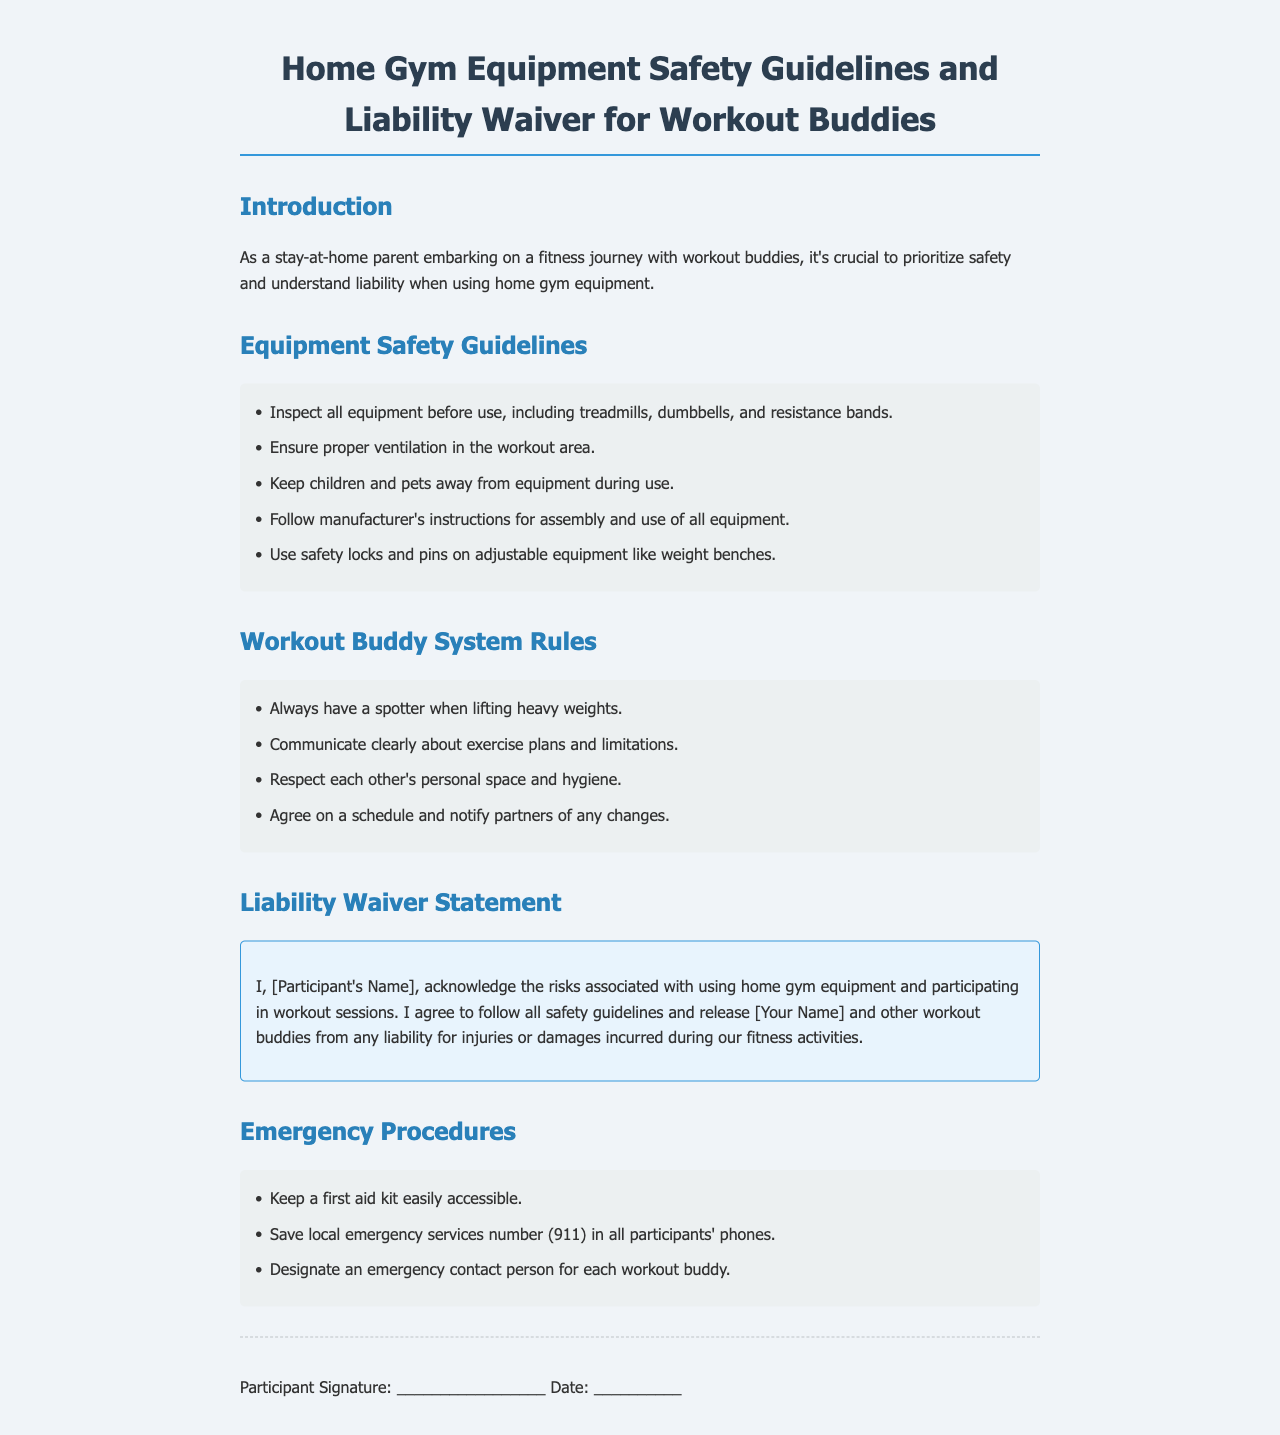what is the title of the document? The title indicates the main subject and purpose of the document, which is about safety guidelines and liability for workout buddies using home gym equipment.
Answer: Home Gym Equipment Safety Guidelines and Liability Waiver for Workout Buddies how many items are listed under Equipment Safety Guidelines? The number of items indicates the comprehensiveness of the safety guidelines provided in the document, which helps ensure proper use of the equipment.
Answer: 5 what is one of the emergency procedures mentioned? This question requires recalling specific safety instructions that emphasize preparedness during fitness activities.
Answer: Keep a first aid kit easily accessible who is released from liability in the waiver statement? Understanding who is released from liability helps workout buddies know the implications of participating in fitness activities together.
Answer: [Your Name] and other workout buddies what should be used on adjustable equipment? This question targets a specific safety precaution that is crucial to prevent accidents while using adjustable gym equipment.
Answer: Safety locks and pins how should workout buddies communicate? This question summarizes an effective communication practice that enhances cooperation and safety among workout partners.
Answer: Clearly about exercise plans and limitations 